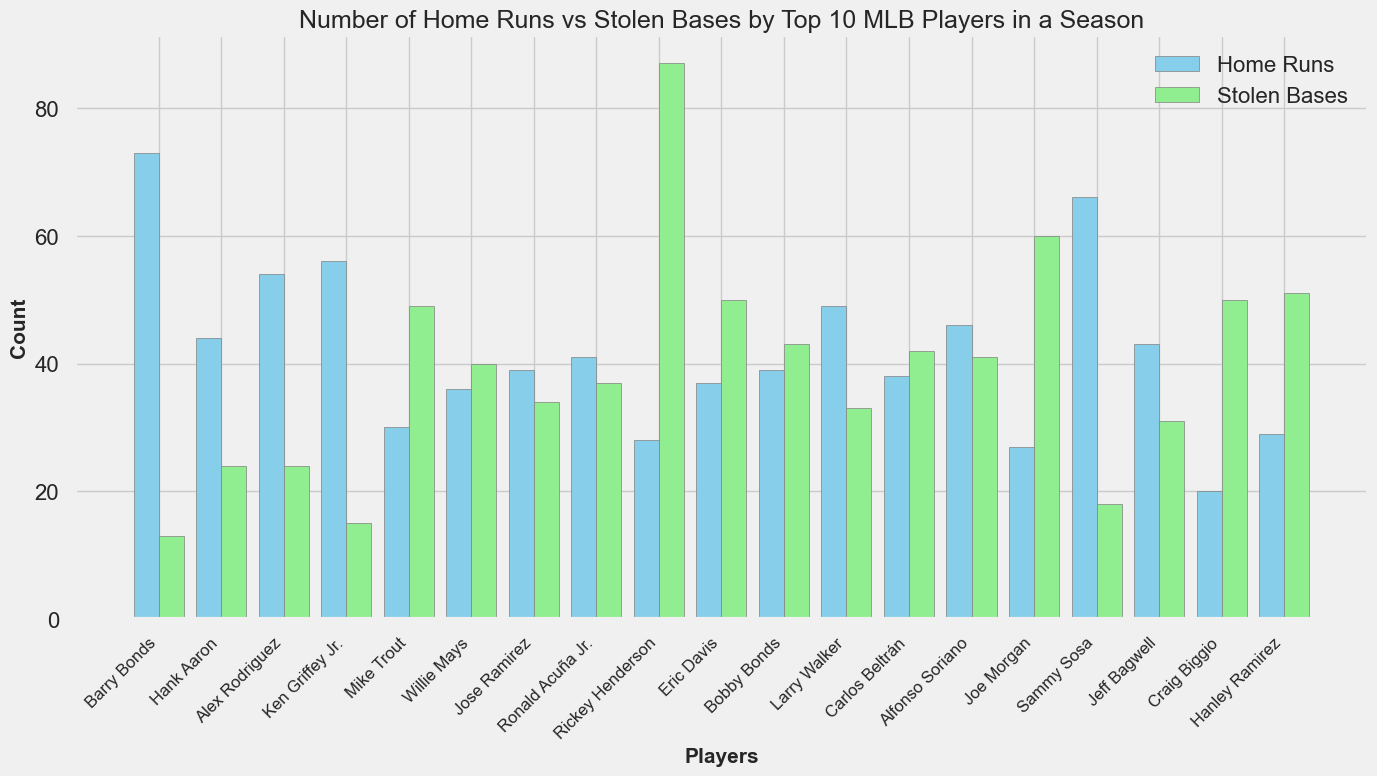Who has the highest number of stolen bases? The figure shows multiple players with their number of stolen bases represented by light green bars. The tallest light green bar represents Rickey Henderson with 87 stolen bases.
Answer: Rickey Henderson Which player has the most home runs, and how does their number of stolen bases compare to the highest stolen base count? Barry Bonds has the most home runs, shown by the highest sky-blue bar. Comparing his stolen bases (13) with Rickey Henderson's (87), he has significantly fewer stolen bases.
Answer: Barry Bonds, 13 vs. 87 Who has more home runs: Ronald Acuña Jr. or Carlos Beltrán? The sky-blue bar for Ronald Acuña Jr. is higher than that of Carlos Beltrán, indicating he has more home runs. Ronald Acuña Jr. has 41 home runs, while Carlos Beltrán has 38.
Answer: Ronald Acuña Jr Which player has the closest number of home runs to Mike Trout's total? Mike Trout has 30 home runs. Eric Davis has 37 home runs, which is the closest among other players.
Answer: Eric Davis What is the combined number of home runs for Jeff Bagwell and Sammy Sosa? Jeff Bagwell has 43 home runs and Sammy Sosa has 66. Summing these values gives 43 + 66 = 109.
Answer: 109 Which player has the largest difference between home runs and stolen bases? The player with the largest difference can be found by visually comparing the height differences between the sky-blue (home runs) and light green (stolen bases) bars. Rickey Henderson has significant fewer home runs (28) compared to his stolen bases (87), giving a difference of 87 - 28 = 59.
Answer: Rickey Henderson Who has a nearly equal number of home runs and stolen bases? The bars for home runs and stolen bases are almost the same height for Alex Rodriguez, who has 54 home runs and 24 stolen bases.
Answer: Alex Rodriguez What is the total number of stolen bases for the players in the dataset? The total can be found by summing all the light green bars. Adding each player's stolen bases: 13 + 24 + 24 + 15 + 49 + 40 + 34 + 37 + 87 + 50 + 43 + 33 + 42 + 41 + 60 + 18 + 31 + 50 + 51 = 701.
Answer: 701 